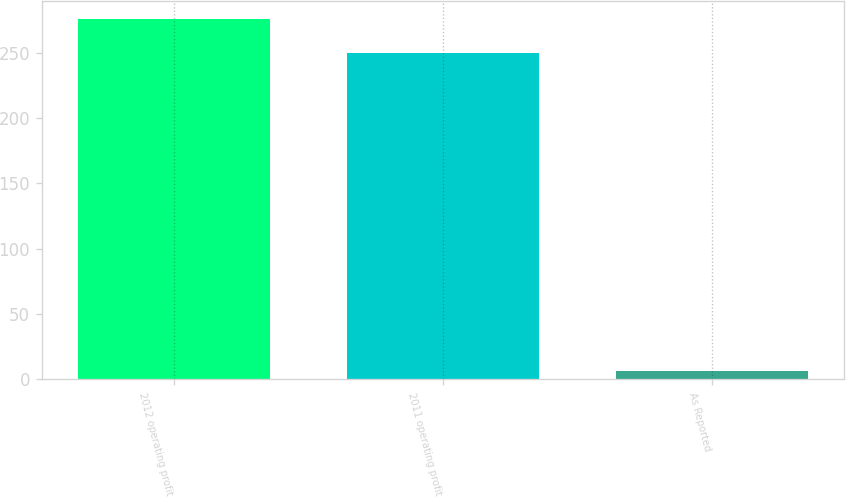Convert chart. <chart><loc_0><loc_0><loc_500><loc_500><bar_chart><fcel>2012 operating profit<fcel>2011 operating profit<fcel>As Reported<nl><fcel>275.88<fcel>250<fcel>6.2<nl></chart> 